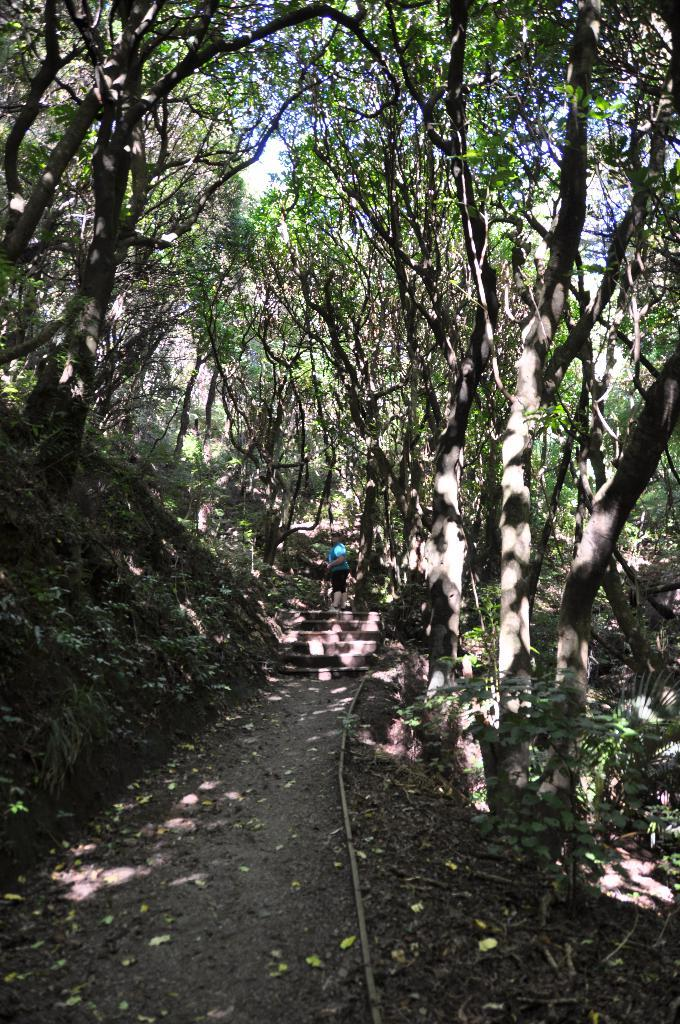What is the main subject of the image? There is a person standing in the image. Where is the person standing? The person is standing on a walkway. What can be seen in the background of the image? There are trees and the sky visible in the background of the image. What type of eggnog is being served to the person in the image? There is no eggnog present in the image; it only features a person standing on a walkway with trees and the sky visible in the background. 